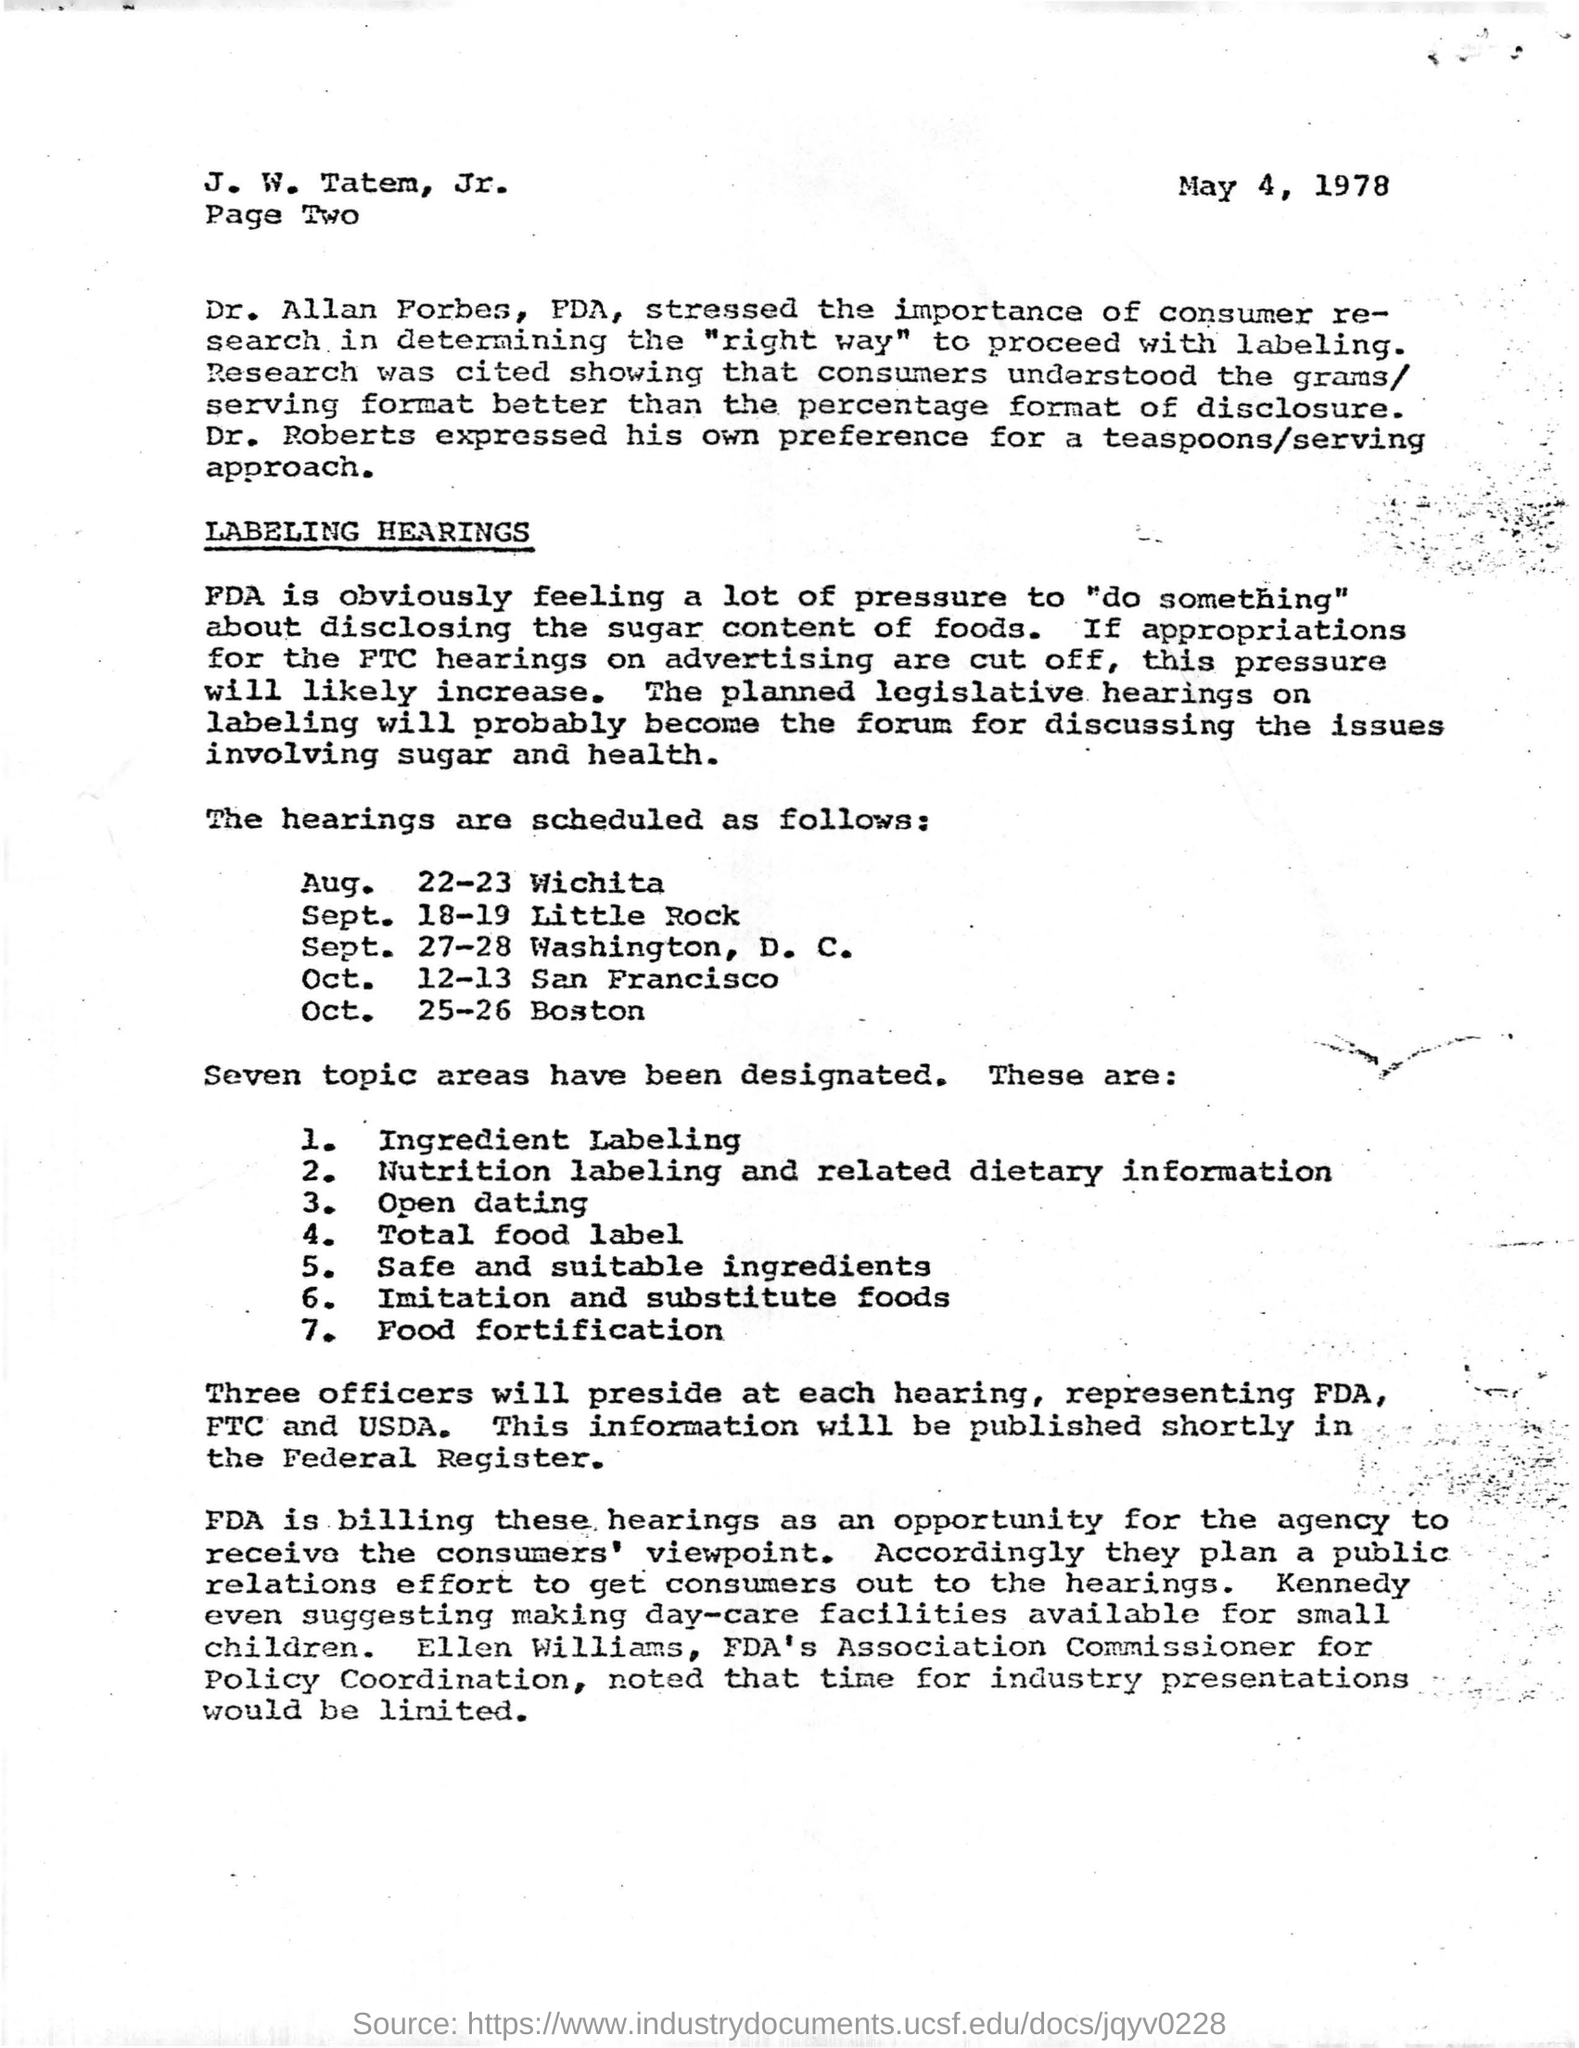Mention a couple of crucial points in this snapshot. The Commissioner for Policy Coordination at the FDA is Ellen Williams. On May 4, 1978, the date mentioned in this letter, ... It is reported that Dr. Roberts expressed a preference for a teaspoons per serving approach. Dr. Allan Forbes emphasized the significance of consumer research in determining the appropriate approach for labeling. I will mention the location where the hearings are scheduled on October 12-13, which is San Francisco. 